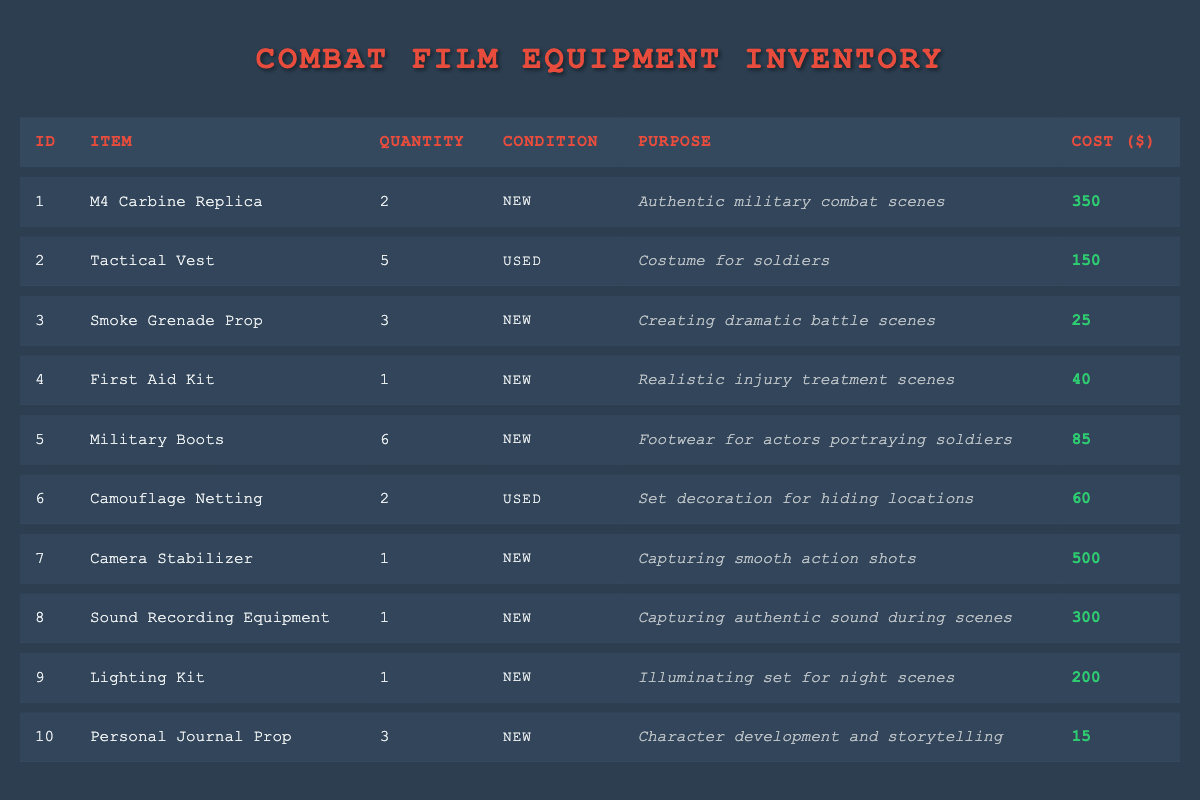What is the total cost of all items in the inventory? To calculate the total cost, sum the individual costs of each item: 350 + 150 + 25 + 40 + 85 + 60 + 500 + 300 + 200 + 15 = 1725.
Answer: 1725 How many smoke grenade props are available? The number of smoke grenade props can be directly found in the table. The quantity listed under "Smoke Grenade Prop" is 3.
Answer: 3 Are there any tactical vests in new condition? The table shows one tactical vest with a condition labeled "Used." Since none are categorized as "New," the answer is no.
Answer: No What is the average cost of items that are new? First, identify the items in new condition: M4 Carbine Replica (350), Smoke Grenade Prop (25), First Aid Kit (40), Military Boots (85), Camera Stabilizer (500), Sound Recording Equipment (300), Lighting Kit (200), and Personal Journal Prop (15). Their total cost is (350 + 25 + 40 + 85 + 500 + 300 + 200 + 15) = 1515. There are 8 new items, so the average cost is 1515 / 8 = 189.375.
Answer: 189.375 Which item has the highest cost, and what is its cost? Reviewing the costs in the table, the "Camera Stabilizer" is the most expensive at $500.
Answer: Camera Stabilizer, 500 How many items are listed as used in the inventory? The table shows two items that have a condition labeled "Used": Tactical Vest and Camouflage Netting. Therefore, there are 2 items in used condition.
Answer: 2 Is the personal journal prop meant for character development and storytelling? The table clearly states under the purpose for "Personal Journal Prop" that it is used for character development and storytelling, confirming the statement is true.
Answer: Yes What is the total quantity of military boots available in the inventory? The quantity of military boots can be found directly in the table, which states that there are 6 military boots available.
Answer: 6 If you need to purchase 5 more smoke grenade props, how many will you have in total? Currently, there are 3 smoke grenade props. Adding the 5 you would purchase gives a new total of 3 + 5 = 8 smoke grenade props.
Answer: 8 